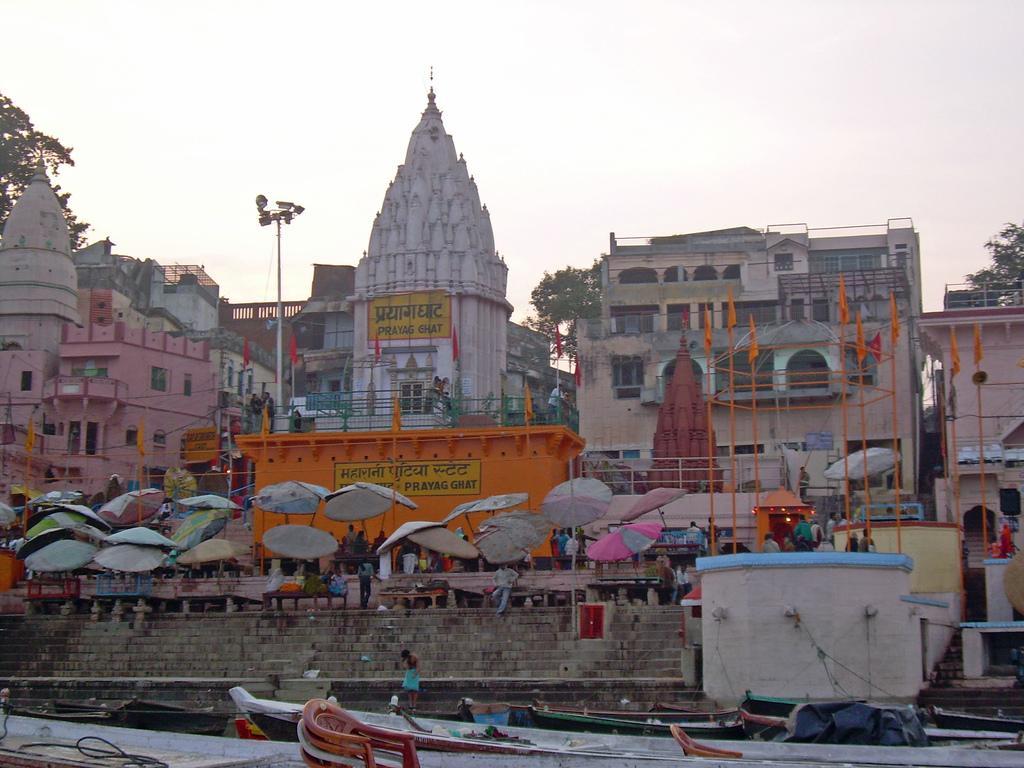Can you describe this image briefly? In this picture I can see at the bottom there are boats, in the middle there are umbrellas. In the background there are buildings and trees, at the top there is the sky. 